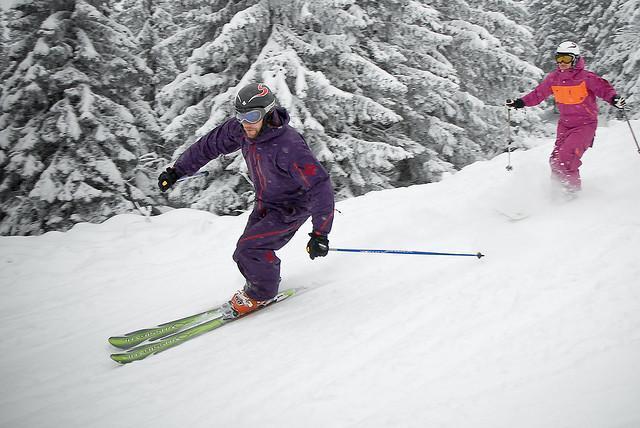How many skiers are in the picture?
Give a very brief answer. 2. How many people are there?
Give a very brief answer. 2. 